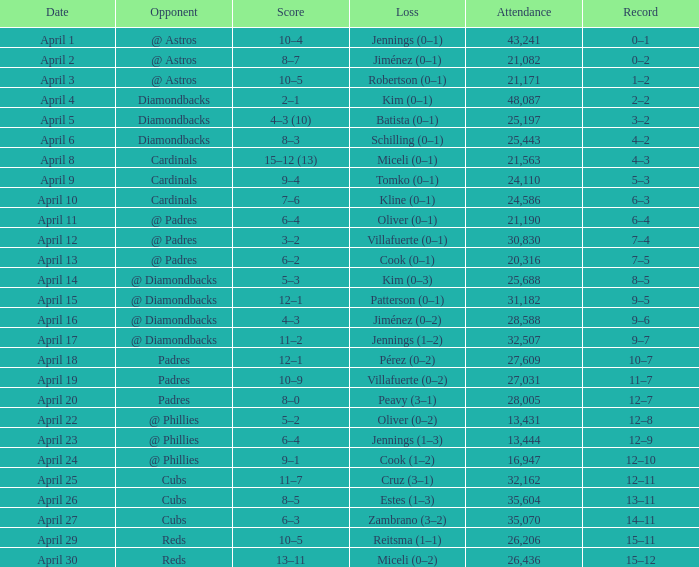What is the team's record on april 23? 12–9. 